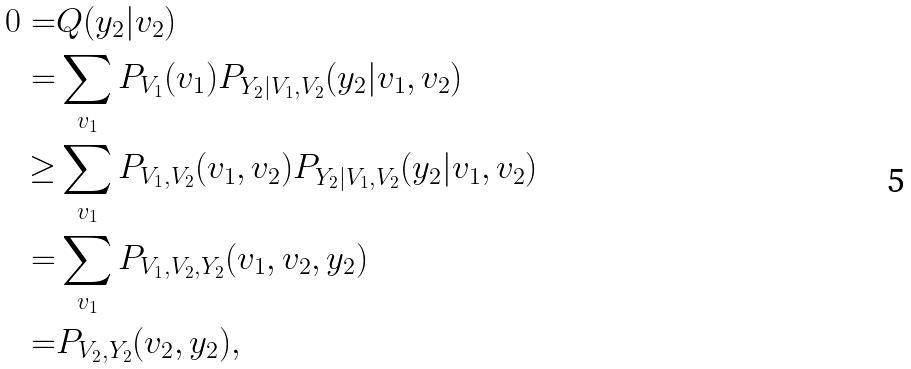<formula> <loc_0><loc_0><loc_500><loc_500>0 = & Q ( y _ { 2 } | v _ { 2 } ) \\ = & \sum _ { v _ { 1 } } P _ { V _ { 1 } } ( v _ { 1 } ) P _ { Y _ { 2 } | V _ { 1 } , V _ { 2 } } ( y _ { 2 } | v _ { 1 } , v _ { 2 } ) \\ \geq & \sum _ { v _ { 1 } } P _ { V _ { 1 } , V _ { 2 } } ( v _ { 1 } , v _ { 2 } ) P _ { Y _ { 2 } | V _ { 1 } , V _ { 2 } } ( y _ { 2 } | v _ { 1 } , v _ { 2 } ) \\ = & \sum _ { v _ { 1 } } P _ { V _ { 1 } , V _ { 2 } , Y _ { 2 } } ( v _ { 1 } , v _ { 2 } , y _ { 2 } ) \\ = & P _ { V _ { 2 } , Y _ { 2 } } ( v _ { 2 } , y _ { 2 } ) ,</formula> 